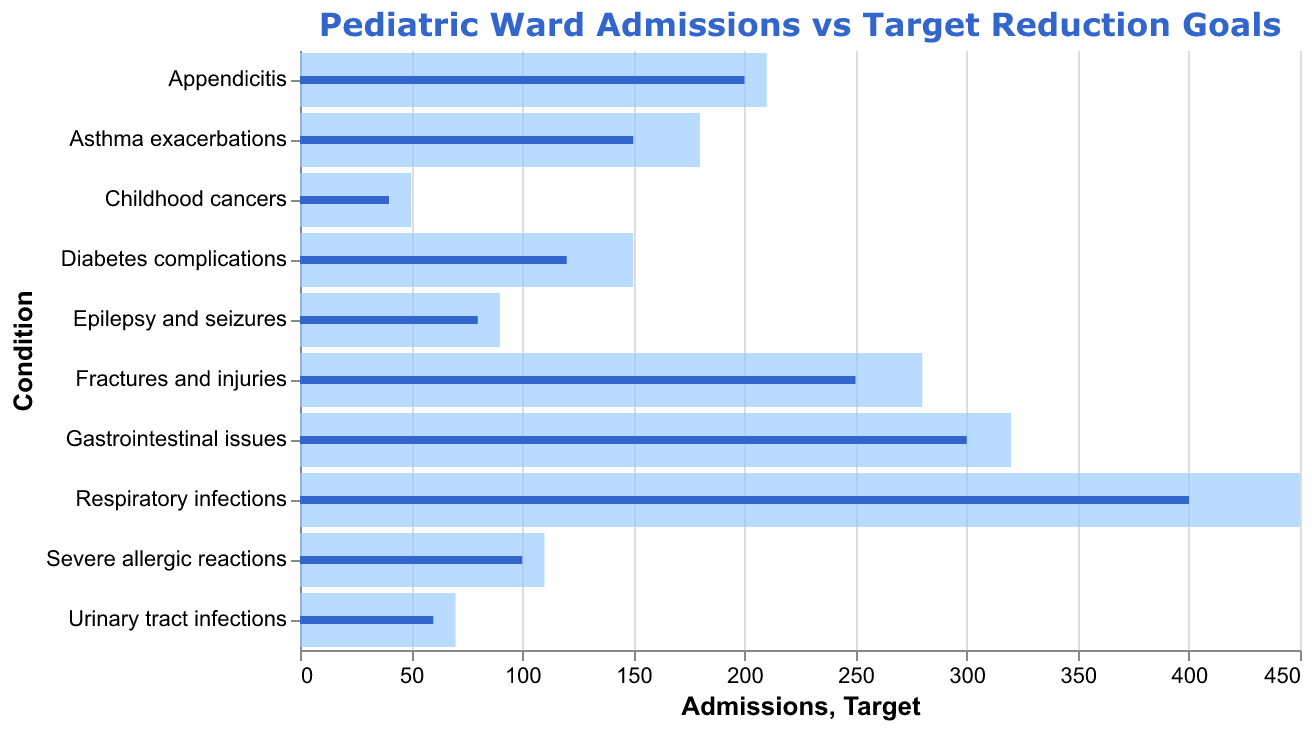What is the title of the figure? The title is located at the top of the figure and specifies what the visualization is about. It reads "Pediatric Ward Admissions vs Target Reduction Goals."
Answer: Pediatric Ward Admissions vs Target Reduction Goals How many conditions are represented in the figure? The number of conditions corresponds to the number of horizontal bars in the chart. Each bar represents one condition. By counting the bars, we can determine that there are 10 conditions.
Answer: 10 Which condition has the highest number of admissions? By comparing the length of the bars, the bar representing "Respiratory infections" is the longest, indicating it has the highest number of admissions.
Answer: Respiratory infections How much higher are the admissions for Respiratory infections compared to its target? Subtract the target value from the admissions value for Respiratory infections (450 - 400).
Answer: 50 What is the color used for the target bars? The target bars are visually distinct and have a different color from the admission bars. They are colored in a dark blue shade.
Answer: Dark blue Which condition has the smallest difference between admissions and target? By observing the bars, the condition "Appendicitis" has the smallest visual difference between the length of the admissions bar and the target bar, demonstrating the smallest gap numerically (210 - 200).
Answer: Appendicitis What is the total number of admissions for conditions related to infections? Add the admissions for Respiratory infections (450), Gastrointestinal issues (320), and Urinary tract infections (70). The total is 450 + 320 + 70 = 840.
Answer: 840 Which conditions have admissions exceeding their targets? Conditions with admission bars longer than their target bars exceed their targets. These are: Respiratory infections, Gastrointestinal issues, Fractures and injuries, Appendicitis, Asthma exacerbations, Diabetes complications, Severe allergic reactions, Epilepsy and seizures, and Urinary tract infections.
Answer: Respiratory infections, Gastrointestinal issues, Fractures and injuries, Appendicitis, Asthma exacerbations, Diabetes complications, Severe allergic reactions, Epilepsy and seizures, Urinary tract infections What is the average target value across all conditions? Sum the target values for all conditions and divide by the number of conditions. (400 + 300 + 250 + 200 + 150 + 120 + 100 + 80 + 60 + 40) / 10 = 1700 / 10 = 170.
Answer: 170 